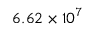Convert formula to latex. <formula><loc_0><loc_0><loc_500><loc_500>6 . 6 2 \times 1 0 ^ { 7 }</formula> 